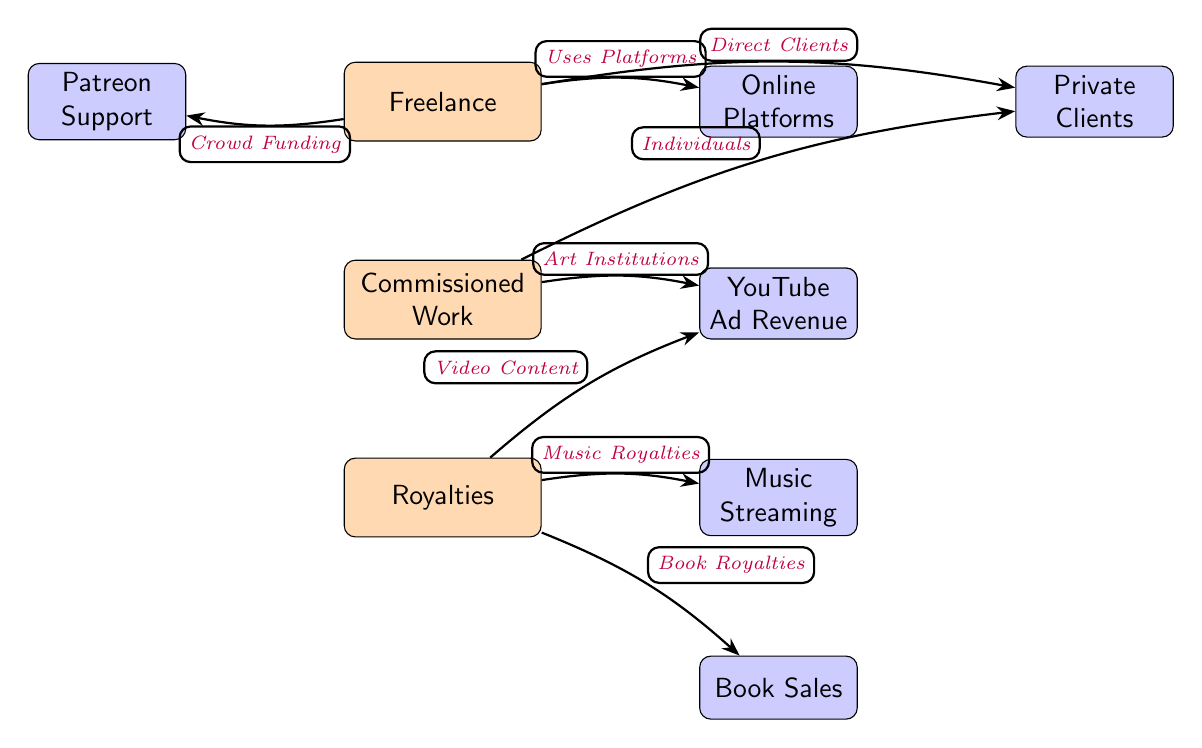What are the main income sources for artists shown in the diagram? The diagram has three main nodes that represent the primary income sources for artists: Freelance, Commissioned Work, and Royalties.
Answer: Freelance, Commissioned Work, Royalties How many sub-nodes are associated with the Freelance income source? The Freelance node has three associated sub-nodes: Online Platforms, Private Clients, and Patreon Support. Therefore, the count is three.
Answer: 3 Which sub-node is related to Book Royalties within the Royalty income source? Within the Royalty node, the sub-node directly related to Book Royalties is labeled as 'Book Sales'. This relationship is explicitly shown in the diagram.
Answer: Book Sales What does the arrow connecting Freelance to Online Platforms indicate? The arrow indicates that the Freelance income source utilizes Online Platforms for generating income. This is explained by the label on the edge, which states "Uses Platforms".
Answer: Uses Platforms How many edges connect the Commissioned Work income source to its sub-nodes? The Commissioned Work node has two edges connecting it to its sub-nodes: one to Private Clients and another to Galleries, resulting in a total of two edges.
Answer: 2 What type of funding is connected to the Freelance node as a sub-source? The Freelance node is connected to Patreon Support, which is categorized as a form of crowd funding in the diagram. This relationship is highlighted by the edge connecting them.
Answer: Crowd Funding Which two sub-nodes of Royalties are focused on video content and music streaming? The two sub-nodes under the Royalty income source that focus on video content and music streaming are YouTube Ad Revenue and Music Streaming, respectively. The diagram provides a direct connection to both sub-nodes.
Answer: YouTube Ad Revenue, Music Streaming What is the relationship between Commissioned Work and Art Institutions? The diagram shows an edge from Commissioned Work to the Galleries sub-node, which represents Art Institutions. The label on the edge describes this connection as coming from Art Institutions.
Answer: Individuals, Art Institutions 